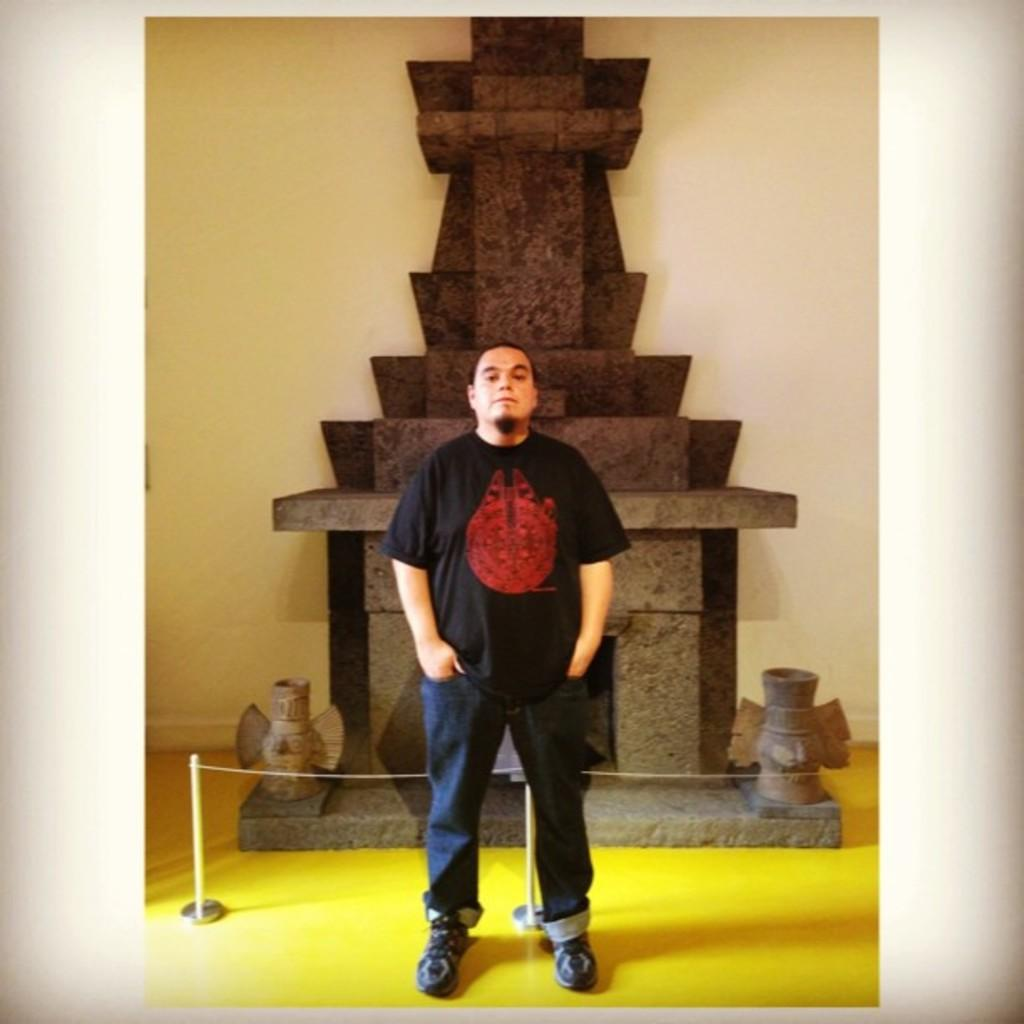What is the main subject of the image? There is a person standing in the image. What is the person doing in the image? The person is posing for a photo. What can be seen in the background of the image? There is a sculpture and a wall in the background of the image. What hobbies does the person have, based on the image? The image does not provide information about the person's hobbies. What is the person experiencing a loss of in the image? There is no indication of loss in the image; the person is simply posing for a photo. 